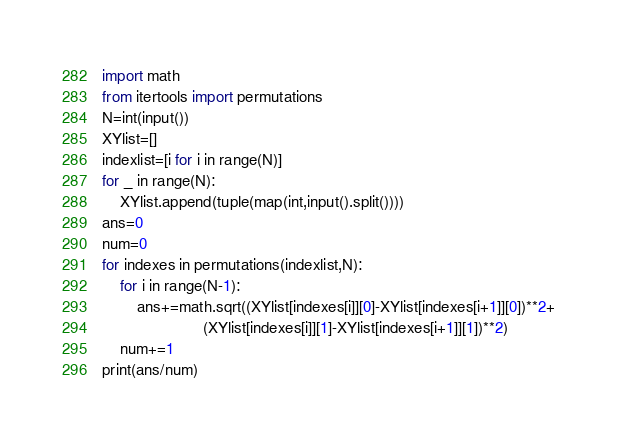<code> <loc_0><loc_0><loc_500><loc_500><_Python_>import math
from itertools import permutations
N=int(input())
XYlist=[]
indexlist=[i for i in range(N)]
for _ in range(N):
    XYlist.append(tuple(map(int,input().split())))
ans=0
num=0
for indexes in permutations(indexlist,N):
    for i in range(N-1):
        ans+=math.sqrt((XYlist[indexes[i]][0]-XYlist[indexes[i+1]][0])**2+
                       (XYlist[indexes[i]][1]-XYlist[indexes[i+1]][1])**2)
    num+=1
print(ans/num)</code> 